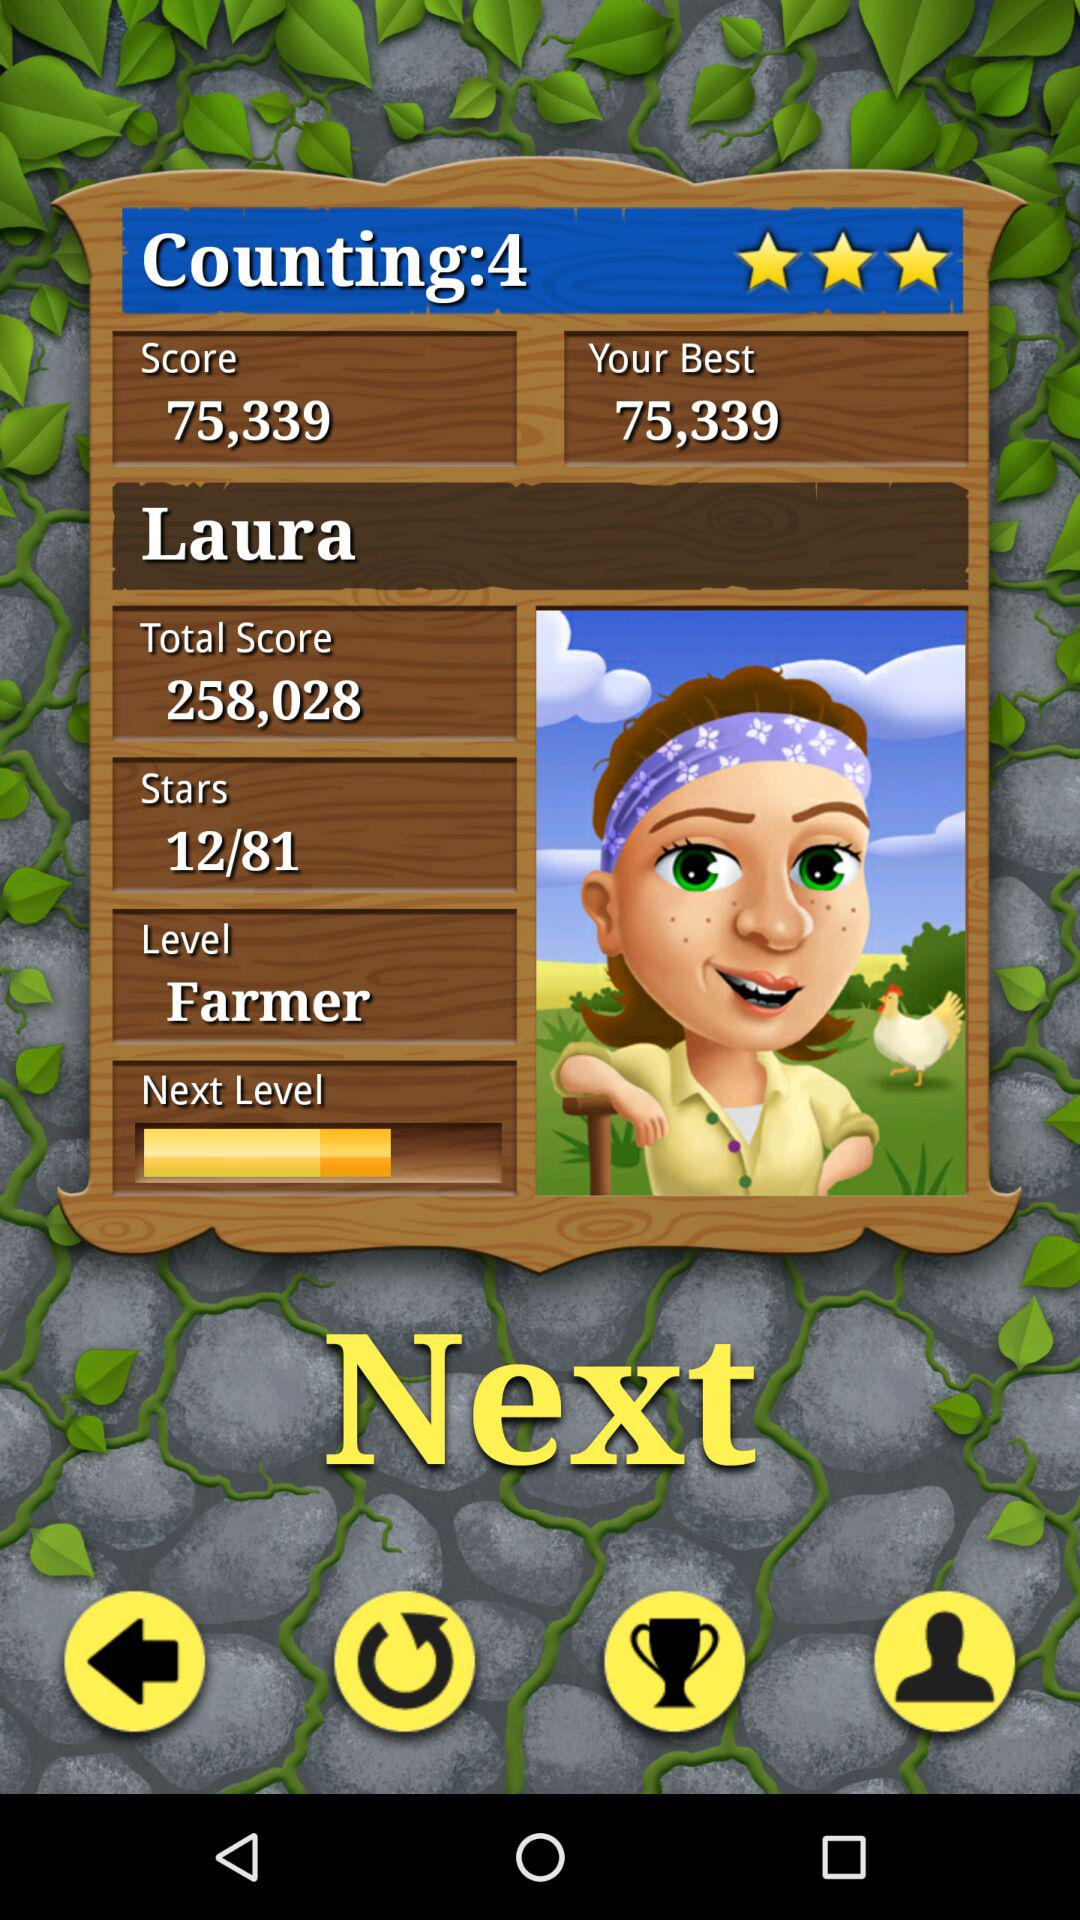What is the score? The score is 75,339. 